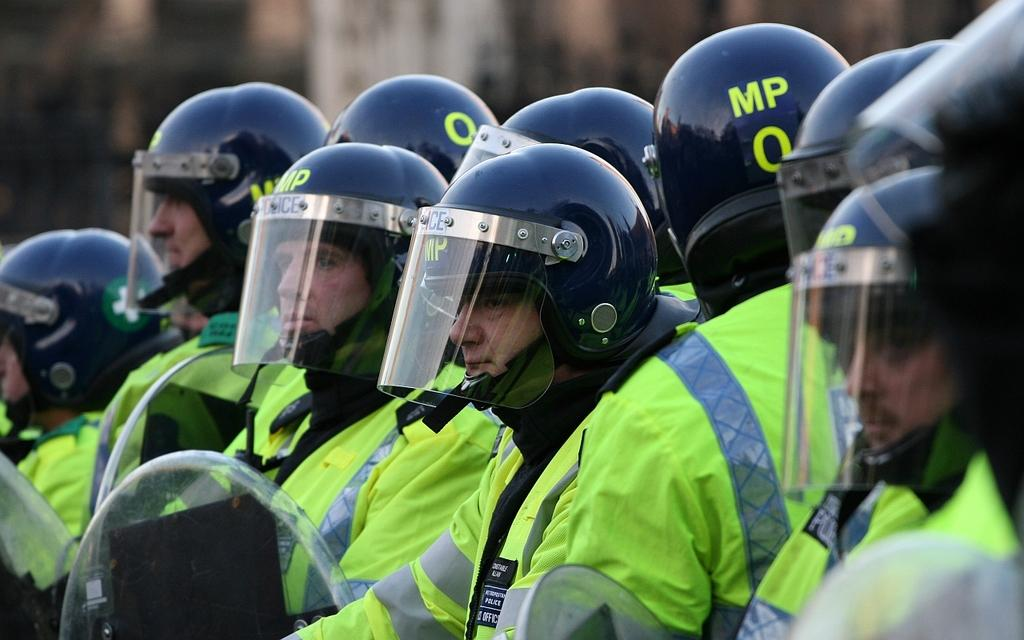Who is present in the image? There are people in the image. Can you describe the gender of the majority of the people? Most of the people are men. What are the men wearing in the image? The men are wearing green color suits. What headgear are the men wearing? The men are wearing helmets on their heads. How would you describe the background of the image? The background of the image is blurred. What plot is being discussed by the ghost in the image? There is no ghost present in the image, so no plot can be discussed. Can you tell me how many chess pieces are visible in the image? There are no chess pieces visible in the image. 